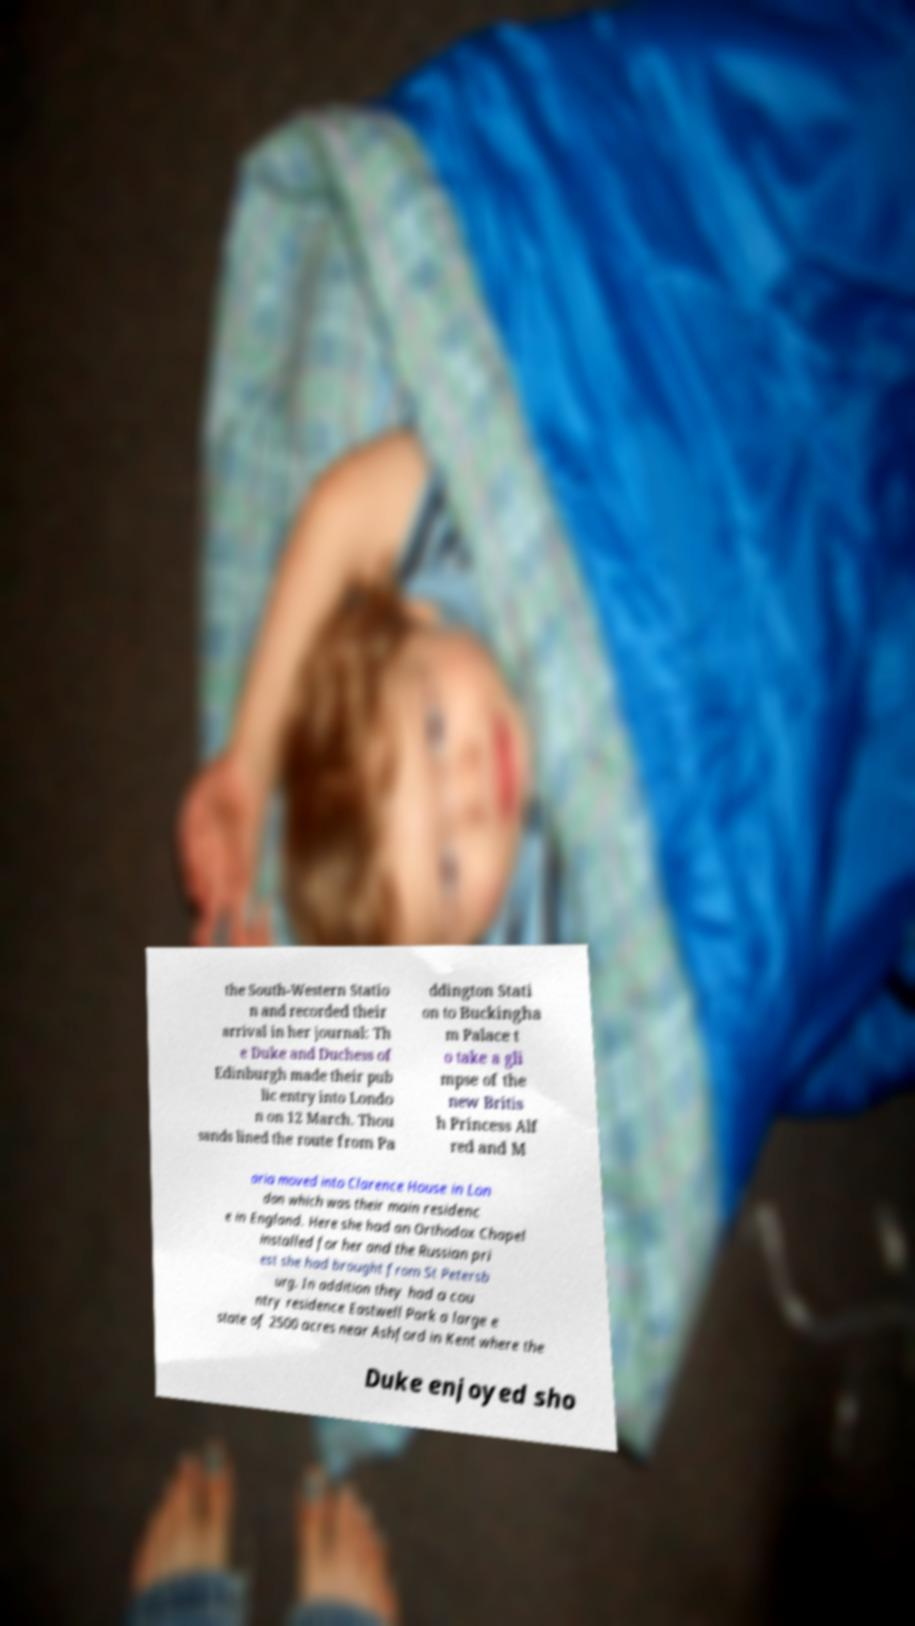Please read and relay the text visible in this image. What does it say? the South-Western Statio n and recorded their arrival in her journal: Th e Duke and Duchess of Edinburgh made their pub lic entry into Londo n on 12 March. Thou sands lined the route from Pa ddington Stati on to Buckingha m Palace t o take a gli mpse of the new Britis h Princess Alf red and M aria moved into Clarence House in Lon don which was their main residenc e in England. Here she had an Orthodox Chapel installed for her and the Russian pri est she had brought from St Petersb urg. In addition they had a cou ntry residence Eastwell Park a large e state of 2500 acres near Ashford in Kent where the Duke enjoyed sho 